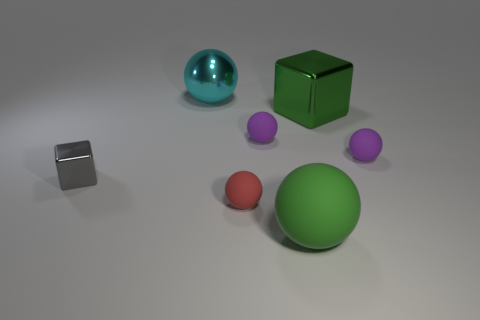Is the size of the gray block the same as the red matte ball?
Ensure brevity in your answer.  Yes. Are there the same number of small rubber balls on the left side of the gray shiny object and small gray shiny blocks that are in front of the large cyan ball?
Provide a succinct answer. No. There is a rubber thing in front of the red matte thing; what shape is it?
Make the answer very short. Sphere. There is a rubber thing that is the same size as the cyan shiny ball; what shape is it?
Your answer should be compact. Sphere. The large ball in front of the thing that is behind the block that is behind the gray shiny cube is what color?
Ensure brevity in your answer.  Green. Is the shape of the green matte thing the same as the cyan object?
Your response must be concise. Yes. Are there the same number of purple rubber things that are behind the large cube and big red spheres?
Provide a succinct answer. Yes. How many other things are made of the same material as the red thing?
Give a very brief answer. 3. Does the object on the left side of the cyan metallic thing have the same size as the green ball on the right side of the shiny sphere?
Make the answer very short. No. What number of objects are either large balls that are in front of the cyan ball or large things behind the green matte object?
Provide a succinct answer. 3. 